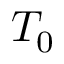Convert formula to latex. <formula><loc_0><loc_0><loc_500><loc_500>T _ { 0 }</formula> 